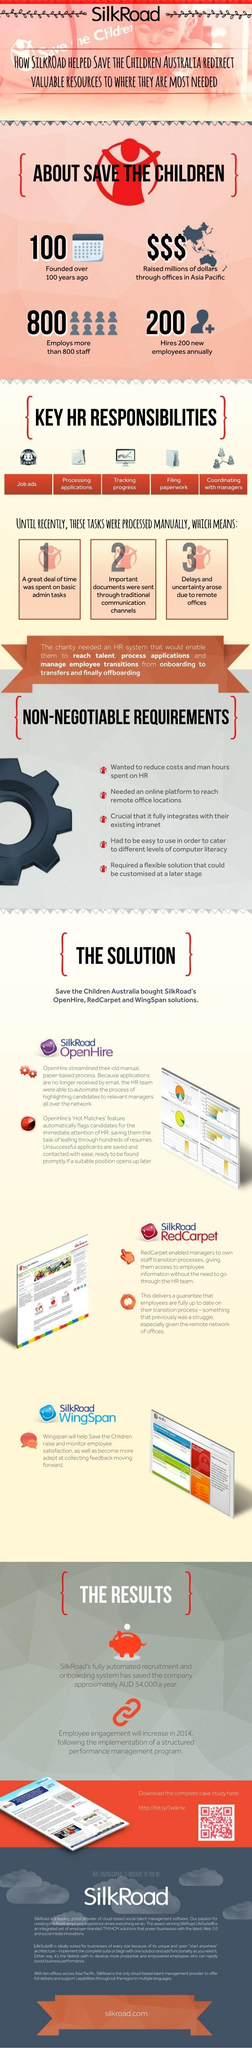How many HR responsibilities mentioned in this infographic?
Answer the question with a short phrase. 5 How many points under the heading "Non-Negotiable Requirements"? 5 